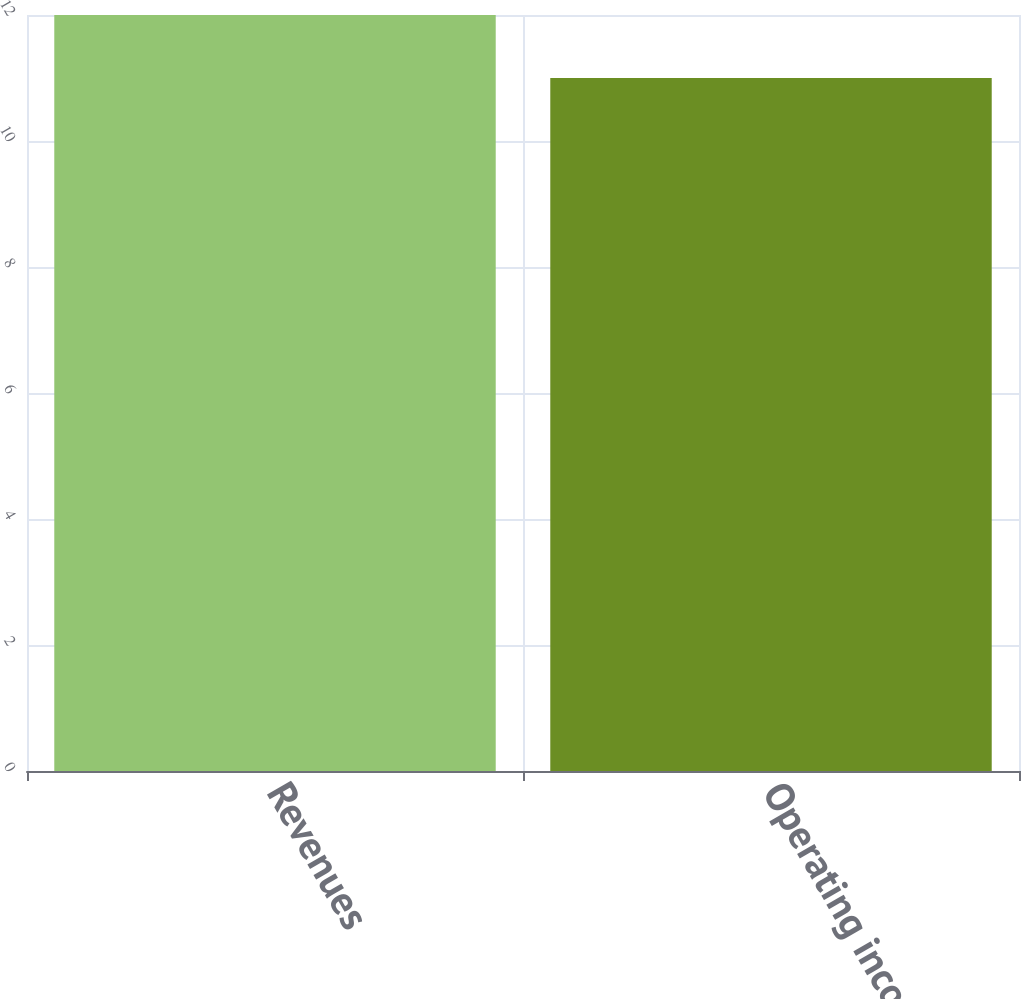Convert chart to OTSL. <chart><loc_0><loc_0><loc_500><loc_500><bar_chart><fcel>Revenues<fcel>Operating income<nl><fcel>12<fcel>11<nl></chart> 